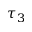Convert formula to latex. <formula><loc_0><loc_0><loc_500><loc_500>\tau _ { 3 }</formula> 